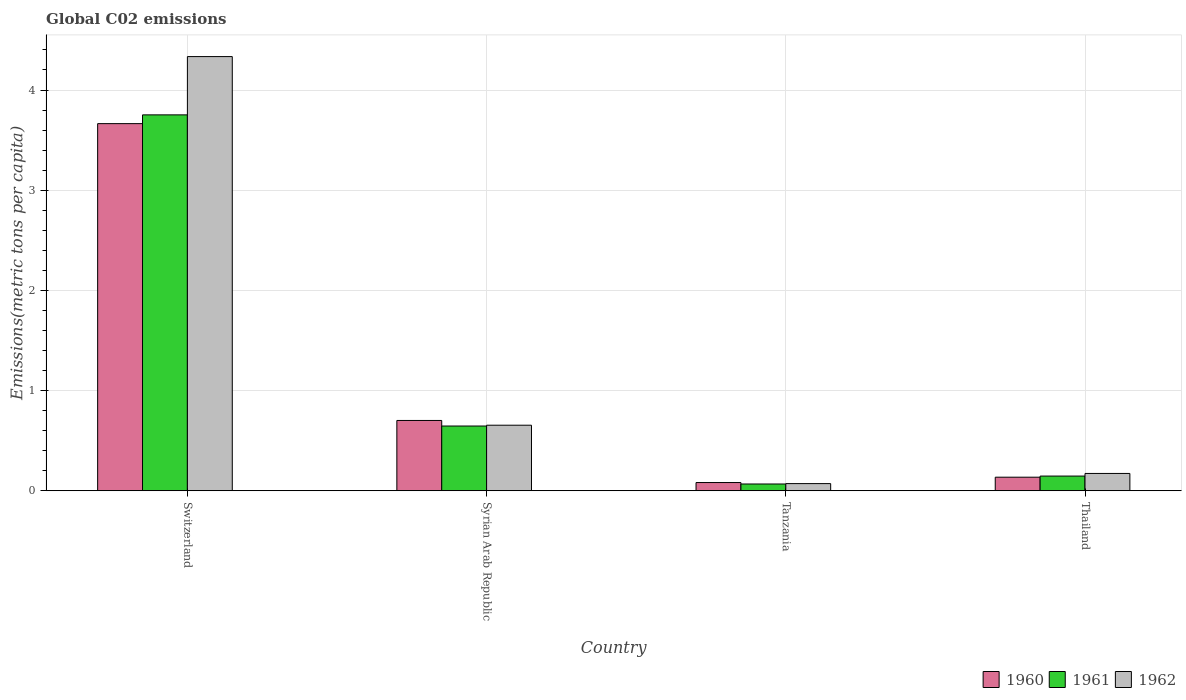How many different coloured bars are there?
Offer a very short reply. 3. Are the number of bars per tick equal to the number of legend labels?
Your answer should be very brief. Yes. Are the number of bars on each tick of the X-axis equal?
Provide a short and direct response. Yes. How many bars are there on the 3rd tick from the right?
Ensure brevity in your answer.  3. What is the label of the 4th group of bars from the left?
Give a very brief answer. Thailand. In how many cases, is the number of bars for a given country not equal to the number of legend labels?
Provide a succinct answer. 0. What is the amount of CO2 emitted in in 1962 in Thailand?
Provide a succinct answer. 0.17. Across all countries, what is the maximum amount of CO2 emitted in in 1962?
Offer a terse response. 4.33. Across all countries, what is the minimum amount of CO2 emitted in in 1961?
Offer a terse response. 0.07. In which country was the amount of CO2 emitted in in 1960 maximum?
Keep it short and to the point. Switzerland. In which country was the amount of CO2 emitted in in 1962 minimum?
Provide a short and direct response. Tanzania. What is the total amount of CO2 emitted in in 1960 in the graph?
Keep it short and to the point. 4.58. What is the difference between the amount of CO2 emitted in in 1960 in Syrian Arab Republic and that in Tanzania?
Provide a short and direct response. 0.62. What is the difference between the amount of CO2 emitted in in 1962 in Switzerland and the amount of CO2 emitted in in 1960 in Tanzania?
Your answer should be very brief. 4.25. What is the average amount of CO2 emitted in in 1961 per country?
Your response must be concise. 1.15. What is the difference between the amount of CO2 emitted in of/in 1962 and amount of CO2 emitted in of/in 1961 in Switzerland?
Ensure brevity in your answer.  0.58. What is the ratio of the amount of CO2 emitted in in 1961 in Syrian Arab Republic to that in Tanzania?
Your answer should be very brief. 9.52. Is the amount of CO2 emitted in in 1960 in Syrian Arab Republic less than that in Tanzania?
Your answer should be compact. No. What is the difference between the highest and the second highest amount of CO2 emitted in in 1962?
Ensure brevity in your answer.  0.48. What is the difference between the highest and the lowest amount of CO2 emitted in in 1960?
Your response must be concise. 3.58. In how many countries, is the amount of CO2 emitted in in 1960 greater than the average amount of CO2 emitted in in 1960 taken over all countries?
Offer a terse response. 1. Is the sum of the amount of CO2 emitted in in 1962 in Syrian Arab Republic and Thailand greater than the maximum amount of CO2 emitted in in 1960 across all countries?
Provide a short and direct response. No. Is it the case that in every country, the sum of the amount of CO2 emitted in in 1961 and amount of CO2 emitted in in 1960 is greater than the amount of CO2 emitted in in 1962?
Provide a short and direct response. Yes. How many bars are there?
Ensure brevity in your answer.  12. What is the difference between two consecutive major ticks on the Y-axis?
Your answer should be very brief. 1. Are the values on the major ticks of Y-axis written in scientific E-notation?
Your response must be concise. No. Does the graph contain grids?
Your response must be concise. Yes. What is the title of the graph?
Provide a short and direct response. Global C02 emissions. Does "2006" appear as one of the legend labels in the graph?
Offer a very short reply. No. What is the label or title of the X-axis?
Your answer should be very brief. Country. What is the label or title of the Y-axis?
Give a very brief answer. Emissions(metric tons per capita). What is the Emissions(metric tons per capita) in 1960 in Switzerland?
Make the answer very short. 3.66. What is the Emissions(metric tons per capita) in 1961 in Switzerland?
Give a very brief answer. 3.75. What is the Emissions(metric tons per capita) of 1962 in Switzerland?
Offer a terse response. 4.33. What is the Emissions(metric tons per capita) in 1960 in Syrian Arab Republic?
Your answer should be very brief. 0.7. What is the Emissions(metric tons per capita) in 1961 in Syrian Arab Republic?
Give a very brief answer. 0.65. What is the Emissions(metric tons per capita) of 1962 in Syrian Arab Republic?
Keep it short and to the point. 0.65. What is the Emissions(metric tons per capita) in 1960 in Tanzania?
Ensure brevity in your answer.  0.08. What is the Emissions(metric tons per capita) in 1961 in Tanzania?
Ensure brevity in your answer.  0.07. What is the Emissions(metric tons per capita) in 1962 in Tanzania?
Offer a very short reply. 0.07. What is the Emissions(metric tons per capita) in 1960 in Thailand?
Offer a very short reply. 0.14. What is the Emissions(metric tons per capita) in 1961 in Thailand?
Keep it short and to the point. 0.15. What is the Emissions(metric tons per capita) in 1962 in Thailand?
Offer a terse response. 0.17. Across all countries, what is the maximum Emissions(metric tons per capita) in 1960?
Your answer should be compact. 3.66. Across all countries, what is the maximum Emissions(metric tons per capita) of 1961?
Give a very brief answer. 3.75. Across all countries, what is the maximum Emissions(metric tons per capita) of 1962?
Offer a very short reply. 4.33. Across all countries, what is the minimum Emissions(metric tons per capita) of 1960?
Offer a terse response. 0.08. Across all countries, what is the minimum Emissions(metric tons per capita) of 1961?
Provide a short and direct response. 0.07. Across all countries, what is the minimum Emissions(metric tons per capita) of 1962?
Make the answer very short. 0.07. What is the total Emissions(metric tons per capita) in 1960 in the graph?
Your response must be concise. 4.58. What is the total Emissions(metric tons per capita) in 1961 in the graph?
Ensure brevity in your answer.  4.61. What is the total Emissions(metric tons per capita) of 1962 in the graph?
Make the answer very short. 5.23. What is the difference between the Emissions(metric tons per capita) of 1960 in Switzerland and that in Syrian Arab Republic?
Your response must be concise. 2.96. What is the difference between the Emissions(metric tons per capita) of 1961 in Switzerland and that in Syrian Arab Republic?
Your response must be concise. 3.11. What is the difference between the Emissions(metric tons per capita) of 1962 in Switzerland and that in Syrian Arab Republic?
Your answer should be very brief. 3.68. What is the difference between the Emissions(metric tons per capita) in 1960 in Switzerland and that in Tanzania?
Offer a very short reply. 3.58. What is the difference between the Emissions(metric tons per capita) in 1961 in Switzerland and that in Tanzania?
Provide a succinct answer. 3.68. What is the difference between the Emissions(metric tons per capita) in 1962 in Switzerland and that in Tanzania?
Offer a very short reply. 4.26. What is the difference between the Emissions(metric tons per capita) in 1960 in Switzerland and that in Thailand?
Ensure brevity in your answer.  3.53. What is the difference between the Emissions(metric tons per capita) of 1961 in Switzerland and that in Thailand?
Offer a terse response. 3.6. What is the difference between the Emissions(metric tons per capita) of 1962 in Switzerland and that in Thailand?
Provide a short and direct response. 4.16. What is the difference between the Emissions(metric tons per capita) in 1960 in Syrian Arab Republic and that in Tanzania?
Your answer should be compact. 0.62. What is the difference between the Emissions(metric tons per capita) of 1961 in Syrian Arab Republic and that in Tanzania?
Ensure brevity in your answer.  0.58. What is the difference between the Emissions(metric tons per capita) of 1962 in Syrian Arab Republic and that in Tanzania?
Your response must be concise. 0.58. What is the difference between the Emissions(metric tons per capita) in 1960 in Syrian Arab Republic and that in Thailand?
Provide a short and direct response. 0.57. What is the difference between the Emissions(metric tons per capita) of 1961 in Syrian Arab Republic and that in Thailand?
Offer a terse response. 0.5. What is the difference between the Emissions(metric tons per capita) of 1962 in Syrian Arab Republic and that in Thailand?
Provide a succinct answer. 0.48. What is the difference between the Emissions(metric tons per capita) of 1960 in Tanzania and that in Thailand?
Offer a terse response. -0.05. What is the difference between the Emissions(metric tons per capita) in 1961 in Tanzania and that in Thailand?
Provide a succinct answer. -0.08. What is the difference between the Emissions(metric tons per capita) in 1962 in Tanzania and that in Thailand?
Make the answer very short. -0.1. What is the difference between the Emissions(metric tons per capita) in 1960 in Switzerland and the Emissions(metric tons per capita) in 1961 in Syrian Arab Republic?
Provide a short and direct response. 3.02. What is the difference between the Emissions(metric tons per capita) in 1960 in Switzerland and the Emissions(metric tons per capita) in 1962 in Syrian Arab Republic?
Keep it short and to the point. 3.01. What is the difference between the Emissions(metric tons per capita) in 1961 in Switzerland and the Emissions(metric tons per capita) in 1962 in Syrian Arab Republic?
Your response must be concise. 3.1. What is the difference between the Emissions(metric tons per capita) in 1960 in Switzerland and the Emissions(metric tons per capita) in 1961 in Tanzania?
Provide a short and direct response. 3.6. What is the difference between the Emissions(metric tons per capita) in 1960 in Switzerland and the Emissions(metric tons per capita) in 1962 in Tanzania?
Give a very brief answer. 3.59. What is the difference between the Emissions(metric tons per capita) of 1961 in Switzerland and the Emissions(metric tons per capita) of 1962 in Tanzania?
Provide a succinct answer. 3.68. What is the difference between the Emissions(metric tons per capita) of 1960 in Switzerland and the Emissions(metric tons per capita) of 1961 in Thailand?
Ensure brevity in your answer.  3.52. What is the difference between the Emissions(metric tons per capita) of 1960 in Switzerland and the Emissions(metric tons per capita) of 1962 in Thailand?
Keep it short and to the point. 3.49. What is the difference between the Emissions(metric tons per capita) in 1961 in Switzerland and the Emissions(metric tons per capita) in 1962 in Thailand?
Your answer should be very brief. 3.58. What is the difference between the Emissions(metric tons per capita) of 1960 in Syrian Arab Republic and the Emissions(metric tons per capita) of 1961 in Tanzania?
Ensure brevity in your answer.  0.63. What is the difference between the Emissions(metric tons per capita) of 1960 in Syrian Arab Republic and the Emissions(metric tons per capita) of 1962 in Tanzania?
Provide a succinct answer. 0.63. What is the difference between the Emissions(metric tons per capita) of 1961 in Syrian Arab Republic and the Emissions(metric tons per capita) of 1962 in Tanzania?
Your answer should be compact. 0.57. What is the difference between the Emissions(metric tons per capita) of 1960 in Syrian Arab Republic and the Emissions(metric tons per capita) of 1961 in Thailand?
Your answer should be compact. 0.55. What is the difference between the Emissions(metric tons per capita) of 1960 in Syrian Arab Republic and the Emissions(metric tons per capita) of 1962 in Thailand?
Make the answer very short. 0.53. What is the difference between the Emissions(metric tons per capita) of 1961 in Syrian Arab Republic and the Emissions(metric tons per capita) of 1962 in Thailand?
Your response must be concise. 0.47. What is the difference between the Emissions(metric tons per capita) in 1960 in Tanzania and the Emissions(metric tons per capita) in 1961 in Thailand?
Keep it short and to the point. -0.06. What is the difference between the Emissions(metric tons per capita) in 1960 in Tanzania and the Emissions(metric tons per capita) in 1962 in Thailand?
Ensure brevity in your answer.  -0.09. What is the difference between the Emissions(metric tons per capita) of 1961 in Tanzania and the Emissions(metric tons per capita) of 1962 in Thailand?
Offer a terse response. -0.11. What is the average Emissions(metric tons per capita) in 1960 per country?
Your answer should be very brief. 1.15. What is the average Emissions(metric tons per capita) of 1961 per country?
Provide a succinct answer. 1.15. What is the average Emissions(metric tons per capita) in 1962 per country?
Your response must be concise. 1.31. What is the difference between the Emissions(metric tons per capita) of 1960 and Emissions(metric tons per capita) of 1961 in Switzerland?
Provide a short and direct response. -0.09. What is the difference between the Emissions(metric tons per capita) of 1960 and Emissions(metric tons per capita) of 1962 in Switzerland?
Your response must be concise. -0.67. What is the difference between the Emissions(metric tons per capita) of 1961 and Emissions(metric tons per capita) of 1962 in Switzerland?
Your response must be concise. -0.58. What is the difference between the Emissions(metric tons per capita) of 1960 and Emissions(metric tons per capita) of 1961 in Syrian Arab Republic?
Your response must be concise. 0.06. What is the difference between the Emissions(metric tons per capita) in 1960 and Emissions(metric tons per capita) in 1962 in Syrian Arab Republic?
Your answer should be very brief. 0.05. What is the difference between the Emissions(metric tons per capita) of 1961 and Emissions(metric tons per capita) of 1962 in Syrian Arab Republic?
Ensure brevity in your answer.  -0.01. What is the difference between the Emissions(metric tons per capita) in 1960 and Emissions(metric tons per capita) in 1961 in Tanzania?
Ensure brevity in your answer.  0.01. What is the difference between the Emissions(metric tons per capita) in 1960 and Emissions(metric tons per capita) in 1962 in Tanzania?
Your answer should be compact. 0.01. What is the difference between the Emissions(metric tons per capita) in 1961 and Emissions(metric tons per capita) in 1962 in Tanzania?
Offer a terse response. -0. What is the difference between the Emissions(metric tons per capita) in 1960 and Emissions(metric tons per capita) in 1961 in Thailand?
Provide a short and direct response. -0.01. What is the difference between the Emissions(metric tons per capita) of 1960 and Emissions(metric tons per capita) of 1962 in Thailand?
Give a very brief answer. -0.04. What is the difference between the Emissions(metric tons per capita) in 1961 and Emissions(metric tons per capita) in 1962 in Thailand?
Your answer should be compact. -0.03. What is the ratio of the Emissions(metric tons per capita) of 1960 in Switzerland to that in Syrian Arab Republic?
Offer a terse response. 5.22. What is the ratio of the Emissions(metric tons per capita) in 1961 in Switzerland to that in Syrian Arab Republic?
Give a very brief answer. 5.8. What is the ratio of the Emissions(metric tons per capita) of 1962 in Switzerland to that in Syrian Arab Republic?
Provide a short and direct response. 6.62. What is the ratio of the Emissions(metric tons per capita) in 1960 in Switzerland to that in Tanzania?
Provide a succinct answer. 44.55. What is the ratio of the Emissions(metric tons per capita) of 1961 in Switzerland to that in Tanzania?
Offer a very short reply. 55.28. What is the ratio of the Emissions(metric tons per capita) of 1962 in Switzerland to that in Tanzania?
Provide a succinct answer. 60.41. What is the ratio of the Emissions(metric tons per capita) of 1960 in Switzerland to that in Thailand?
Your response must be concise. 27.03. What is the ratio of the Emissions(metric tons per capita) of 1961 in Switzerland to that in Thailand?
Provide a succinct answer. 25.53. What is the ratio of the Emissions(metric tons per capita) of 1962 in Switzerland to that in Thailand?
Keep it short and to the point. 25.03. What is the ratio of the Emissions(metric tons per capita) of 1960 in Syrian Arab Republic to that in Tanzania?
Offer a terse response. 8.53. What is the ratio of the Emissions(metric tons per capita) in 1961 in Syrian Arab Republic to that in Tanzania?
Your answer should be compact. 9.52. What is the ratio of the Emissions(metric tons per capita) of 1962 in Syrian Arab Republic to that in Tanzania?
Provide a short and direct response. 9.12. What is the ratio of the Emissions(metric tons per capita) in 1960 in Syrian Arab Republic to that in Thailand?
Ensure brevity in your answer.  5.18. What is the ratio of the Emissions(metric tons per capita) in 1961 in Syrian Arab Republic to that in Thailand?
Provide a short and direct response. 4.4. What is the ratio of the Emissions(metric tons per capita) in 1962 in Syrian Arab Republic to that in Thailand?
Offer a very short reply. 3.78. What is the ratio of the Emissions(metric tons per capita) of 1960 in Tanzania to that in Thailand?
Offer a very short reply. 0.61. What is the ratio of the Emissions(metric tons per capita) in 1961 in Tanzania to that in Thailand?
Your answer should be compact. 0.46. What is the ratio of the Emissions(metric tons per capita) of 1962 in Tanzania to that in Thailand?
Provide a short and direct response. 0.41. What is the difference between the highest and the second highest Emissions(metric tons per capita) in 1960?
Offer a very short reply. 2.96. What is the difference between the highest and the second highest Emissions(metric tons per capita) in 1961?
Provide a succinct answer. 3.11. What is the difference between the highest and the second highest Emissions(metric tons per capita) in 1962?
Your response must be concise. 3.68. What is the difference between the highest and the lowest Emissions(metric tons per capita) of 1960?
Offer a very short reply. 3.58. What is the difference between the highest and the lowest Emissions(metric tons per capita) of 1961?
Offer a very short reply. 3.68. What is the difference between the highest and the lowest Emissions(metric tons per capita) in 1962?
Your answer should be very brief. 4.26. 